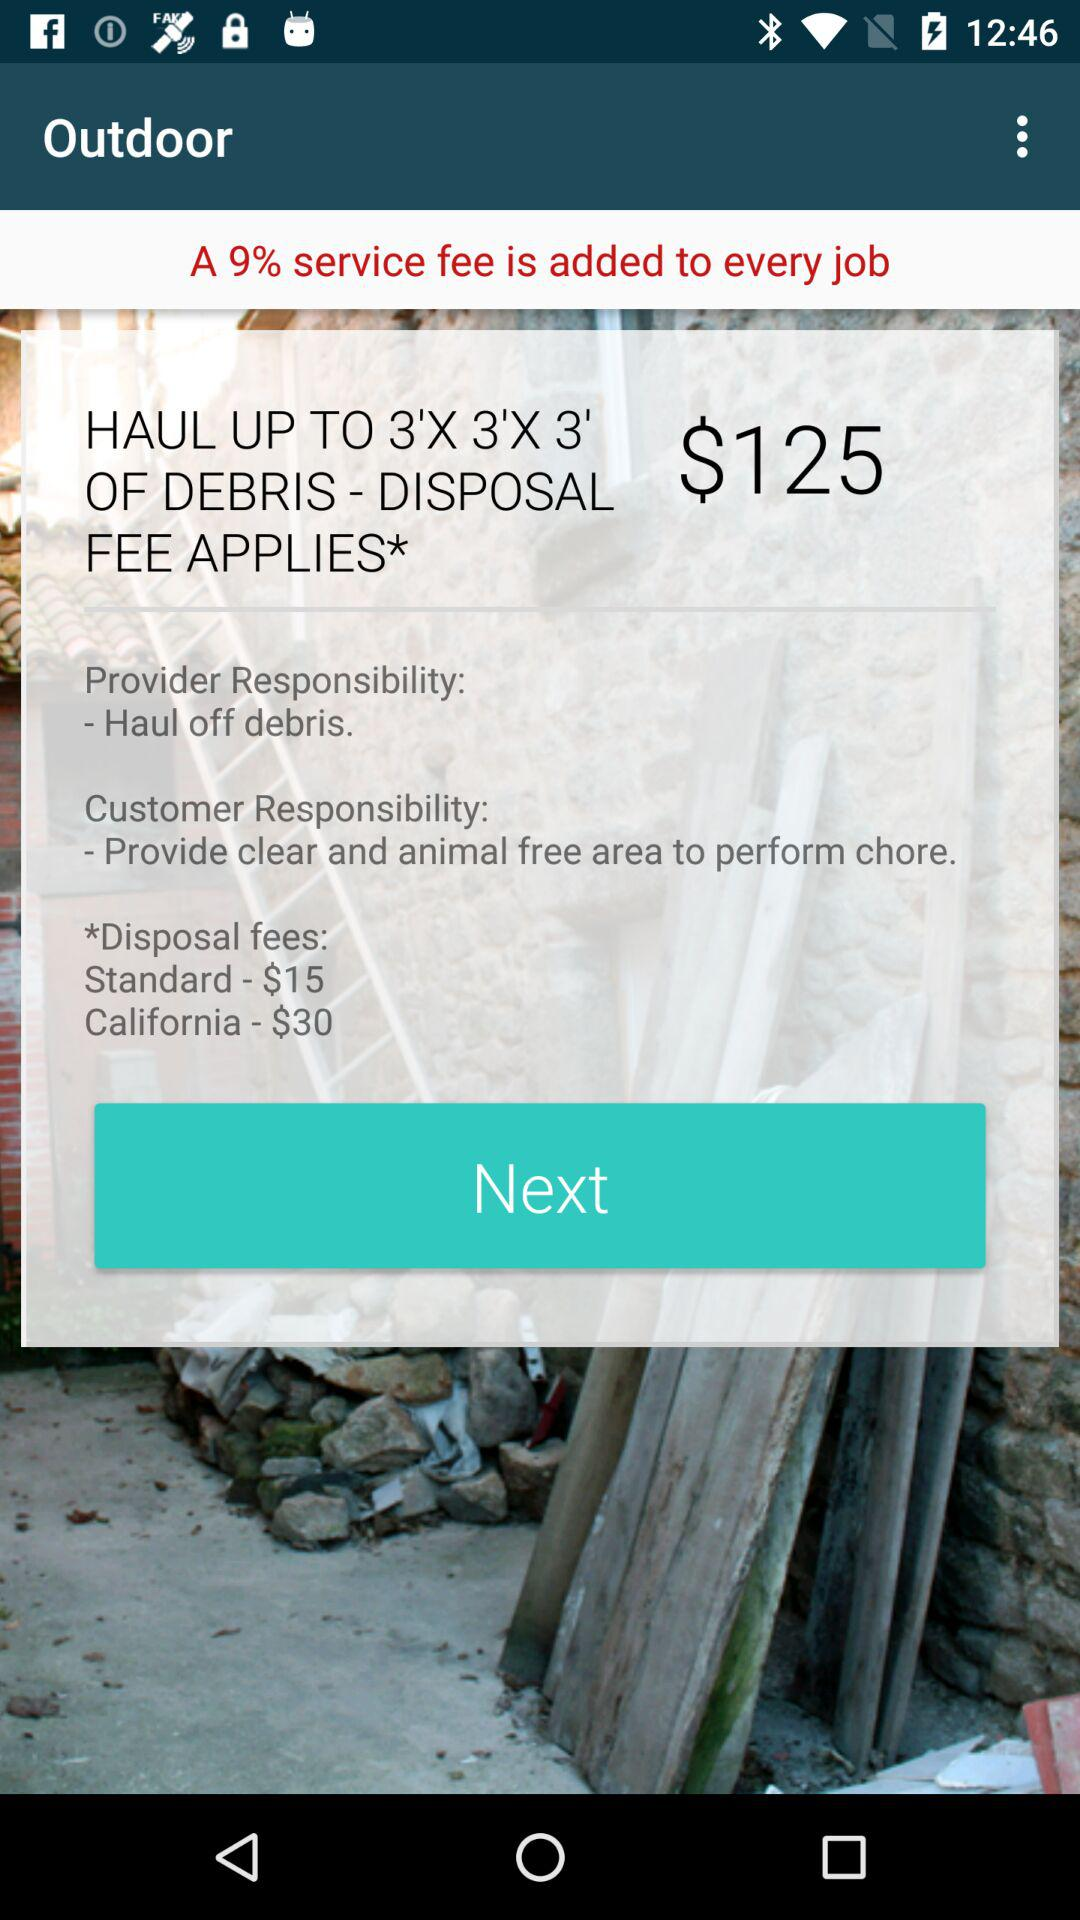How much more does it cost to dispose of debris in California than standard disposal?
Answer the question using a single word or phrase. $15 